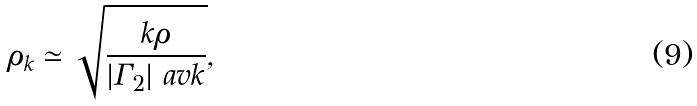<formula> <loc_0><loc_0><loc_500><loc_500>\rho _ { k } \simeq \sqrt { \frac { k \rho } { | \Gamma _ { 2 } | \ a v k } } ,</formula> 